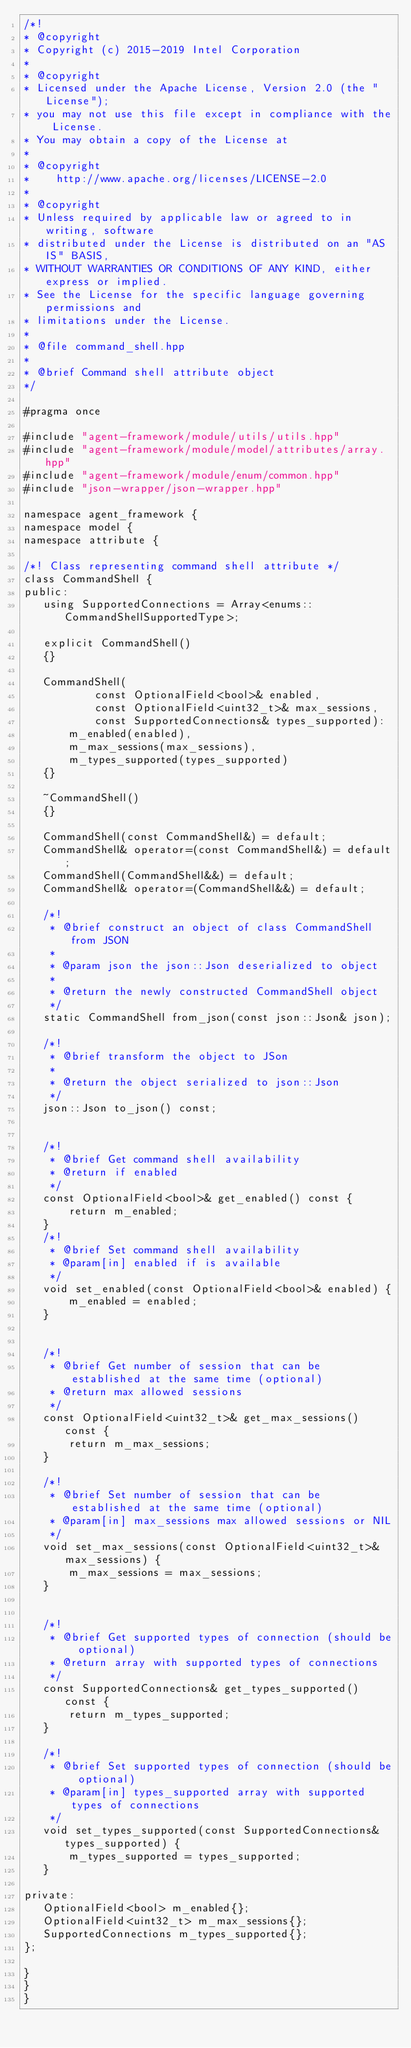<code> <loc_0><loc_0><loc_500><loc_500><_C++_>/*!
* @copyright
* Copyright (c) 2015-2019 Intel Corporation
*
* @copyright
* Licensed under the Apache License, Version 2.0 (the "License");
* you may not use this file except in compliance with the License.
* You may obtain a copy of the License at
*
* @copyright
*    http://www.apache.org/licenses/LICENSE-2.0
*
* @copyright
* Unless required by applicable law or agreed to in writing, software
* distributed under the License is distributed on an "AS IS" BASIS,
* WITHOUT WARRANTIES OR CONDITIONS OF ANY KIND, either express or implied.
* See the License for the specific language governing permissions and
* limitations under the License.
*
* @file command_shell.hpp
*
* @brief Command shell attribute object
*/

#pragma once

#include "agent-framework/module/utils/utils.hpp"
#include "agent-framework/module/model/attributes/array.hpp"
#include "agent-framework/module/enum/common.hpp"
#include "json-wrapper/json-wrapper.hpp"

namespace agent_framework {
namespace model {
namespace attribute {

/*! Class representing command shell attribute */
class CommandShell {
public:
   using SupportedConnections = Array<enums::CommandShellSupportedType>;

   explicit CommandShell()
   {}

   CommandShell(
           const OptionalField<bool>& enabled,
           const OptionalField<uint32_t>& max_sessions,
           const SupportedConnections& types_supported):
       m_enabled(enabled),
       m_max_sessions(max_sessions),
       m_types_supported(types_supported)
   {}

   ~CommandShell()
   {}

   CommandShell(const CommandShell&) = default;
   CommandShell& operator=(const CommandShell&) = default;
   CommandShell(CommandShell&&) = default;
   CommandShell& operator=(CommandShell&&) = default;

   /*!
    * @brief construct an object of class CommandShell from JSON
    *
    * @param json the json::Json deserialized to object
    *
    * @return the newly constructed CommandShell object
    */
   static CommandShell from_json(const json::Json& json);

   /*!
    * @brief transform the object to JSon
    *
    * @return the object serialized to json::Json
    */
   json::Json to_json() const;


   /*!
    * @brief Get command shell availability
    * @return if enabled
    */
   const OptionalField<bool>& get_enabled() const {
       return m_enabled;
   }
   /*!
    * @brief Set command shell availability
    * @param[in] enabled if is available
    */
   void set_enabled(const OptionalField<bool>& enabled) {
       m_enabled = enabled;
   }


   /*!
    * @brief Get number of session that can be established at the same time (optional)
    * @return max allowed sessions
    */
   const OptionalField<uint32_t>& get_max_sessions() const {
       return m_max_sessions;
   }

   /*!
    * @brief Set number of session that can be established at the same time (optional)
    * @param[in] max_sessions max allowed sessions or NIL
    */
   void set_max_sessions(const OptionalField<uint32_t>& max_sessions) {
       m_max_sessions = max_sessions;
   }


   /*!
    * @brief Get supported types of connection (should be optional)
    * @return array with supported types of connections
    */
   const SupportedConnections& get_types_supported() const {
       return m_types_supported;
   }

   /*!
    * @brief Set supported types of connection (should be optional)
    * @param[in] types_supported array with supported types of connections
    */
   void set_types_supported(const SupportedConnections& types_supported) {
       m_types_supported = types_supported;
   }

private:
   OptionalField<bool> m_enabled{};
   OptionalField<uint32_t> m_max_sessions{};
   SupportedConnections m_types_supported{};
};

}
}
}
</code> 